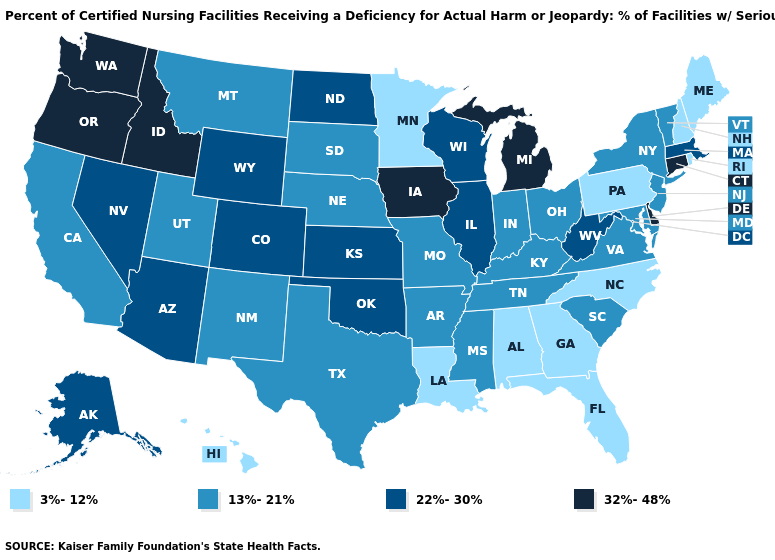Does New York have a lower value than Oregon?
Concise answer only. Yes. What is the highest value in the USA?
Short answer required. 32%-48%. Does Vermont have the highest value in the USA?
Write a very short answer. No. What is the value of Tennessee?
Answer briefly. 13%-21%. What is the value of South Dakota?
Quick response, please. 13%-21%. Name the states that have a value in the range 13%-21%?
Concise answer only. Arkansas, California, Indiana, Kentucky, Maryland, Mississippi, Missouri, Montana, Nebraska, New Jersey, New Mexico, New York, Ohio, South Carolina, South Dakota, Tennessee, Texas, Utah, Vermont, Virginia. Name the states that have a value in the range 22%-30%?
Short answer required. Alaska, Arizona, Colorado, Illinois, Kansas, Massachusetts, Nevada, North Dakota, Oklahoma, West Virginia, Wisconsin, Wyoming. What is the highest value in the USA?
Be succinct. 32%-48%. Among the states that border Alabama , does Florida have the highest value?
Short answer required. No. What is the value of Washington?
Be succinct. 32%-48%. What is the value of Indiana?
Answer briefly. 13%-21%. Name the states that have a value in the range 13%-21%?
Concise answer only. Arkansas, California, Indiana, Kentucky, Maryland, Mississippi, Missouri, Montana, Nebraska, New Jersey, New Mexico, New York, Ohio, South Carolina, South Dakota, Tennessee, Texas, Utah, Vermont, Virginia. What is the value of North Carolina?
Be succinct. 3%-12%. Does Minnesota have the highest value in the MidWest?
Quick response, please. No. 